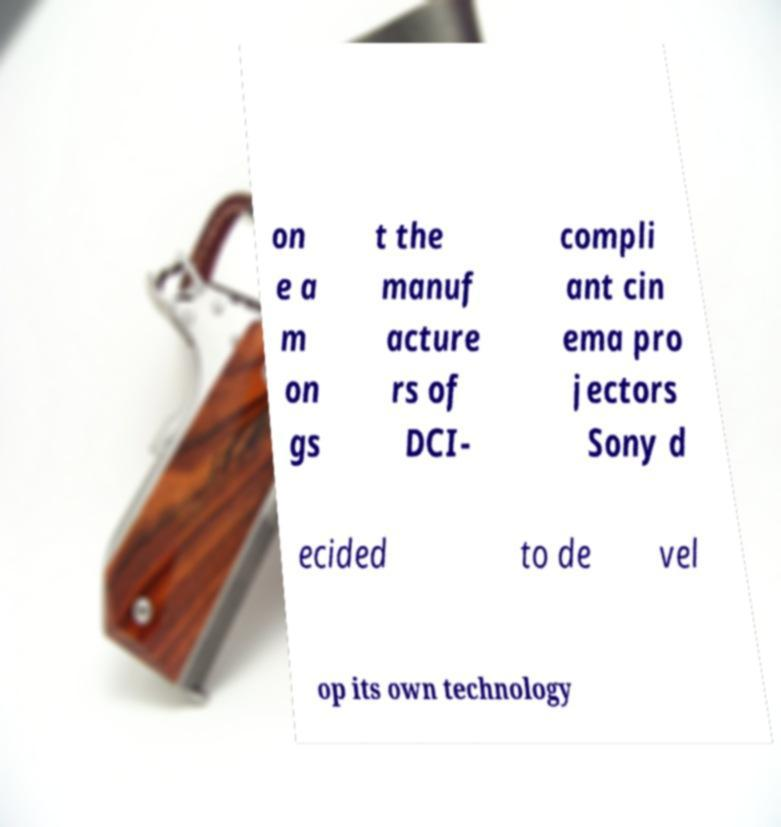For documentation purposes, I need the text within this image transcribed. Could you provide that? on e a m on gs t the manuf acture rs of DCI- compli ant cin ema pro jectors Sony d ecided to de vel op its own technology 